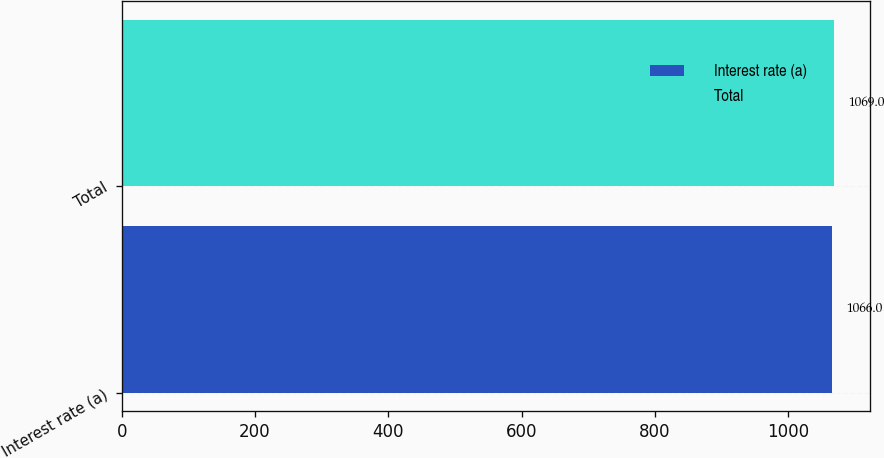Convert chart. <chart><loc_0><loc_0><loc_500><loc_500><bar_chart><fcel>Interest rate (a)<fcel>Total<nl><fcel>1066<fcel>1069<nl></chart> 